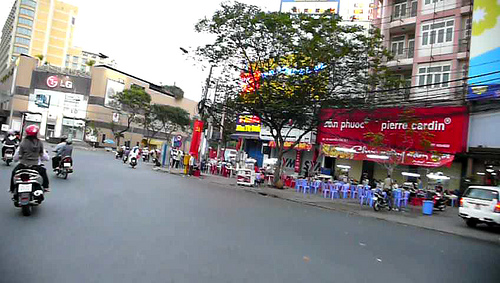What color is the flower? The flower visible in the image is yellow. 